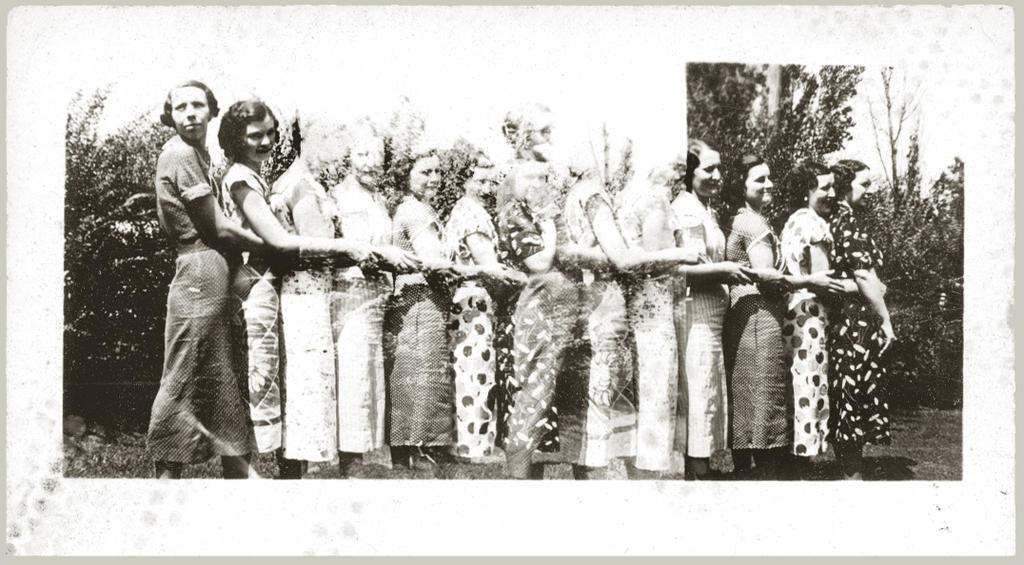What is the color scheme of the image? The image is black and white. Who is present in the image? There are women in the image. How are the women positioned in the image? The women are standing in a row. What are the women doing in the image? The women are holding their hands. How many chairs are visible in the image? There are no chairs present in the image. What type of drain is visible in the image? There is no drain present in the image. 